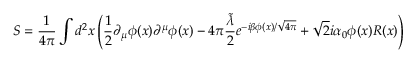<formula> <loc_0><loc_0><loc_500><loc_500>S = \frac { 1 } { 4 \pi } \int d ^ { 2 } x \left ( \frac { 1 } { 2 } \partial _ { \mu } \phi ( x ) \partial ^ { \mu } \phi ( x ) - 4 \pi \frac { \tilde { \lambda } } { 2 } e ^ { - i \beta \phi ( x ) / \sqrt { 4 \pi } } + \sqrt { 2 } i \alpha _ { 0 } \phi ( x ) R ( x ) \right )</formula> 